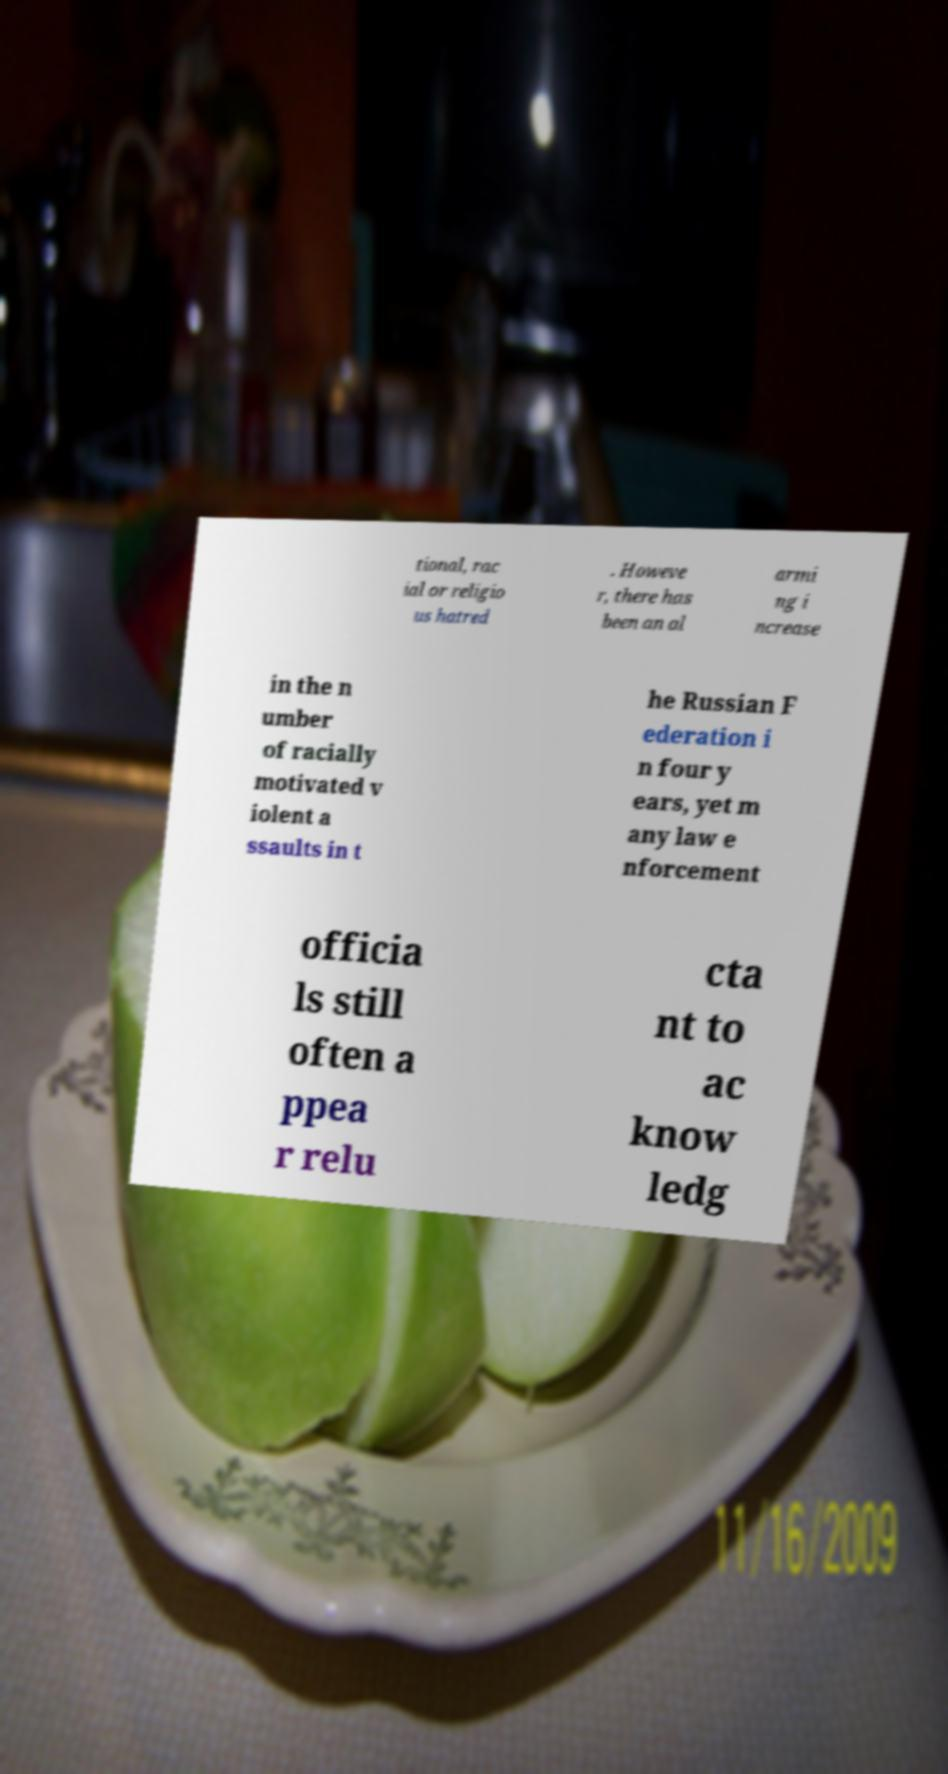Could you assist in decoding the text presented in this image and type it out clearly? tional, rac ial or religio us hatred . Howeve r, there has been an al armi ng i ncrease in the n umber of racially motivated v iolent a ssaults in t he Russian F ederation i n four y ears, yet m any law e nforcement officia ls still often a ppea r relu cta nt to ac know ledg 